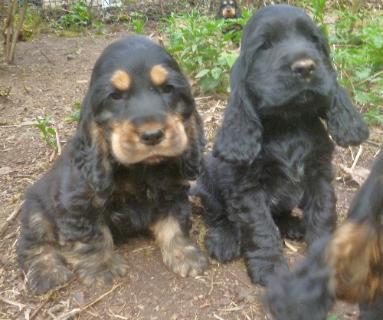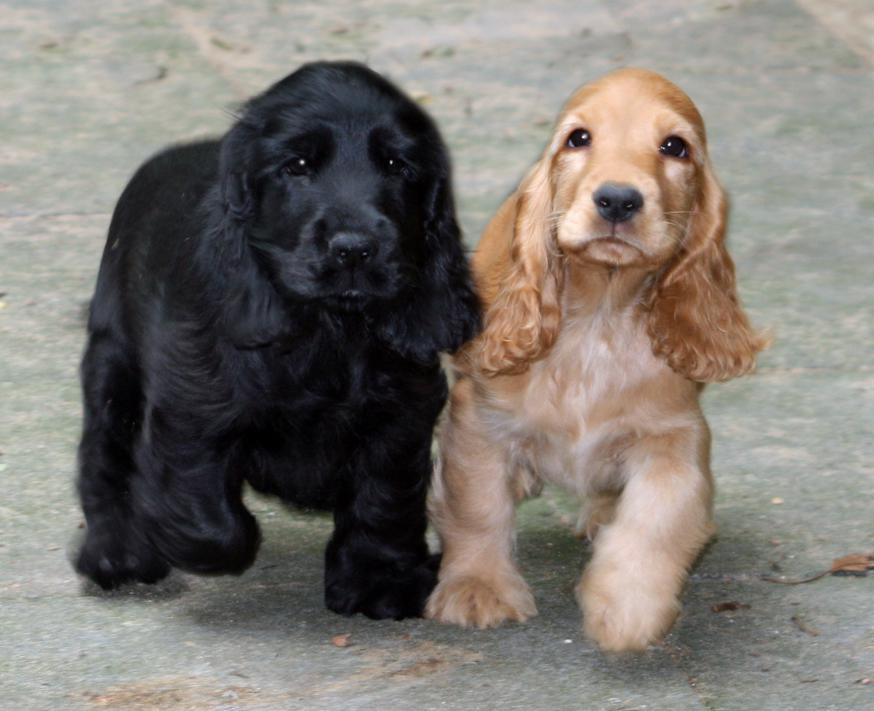The first image is the image on the left, the second image is the image on the right. Evaluate the accuracy of this statement regarding the images: "An all black puppy and an all brown puppy are next to each other.". Is it true? Answer yes or no. Yes. The first image is the image on the left, the second image is the image on the right. Examine the images to the left and right. Is the description "There is a tan dog beside a black dog in one of the images." accurate? Answer yes or no. Yes. 